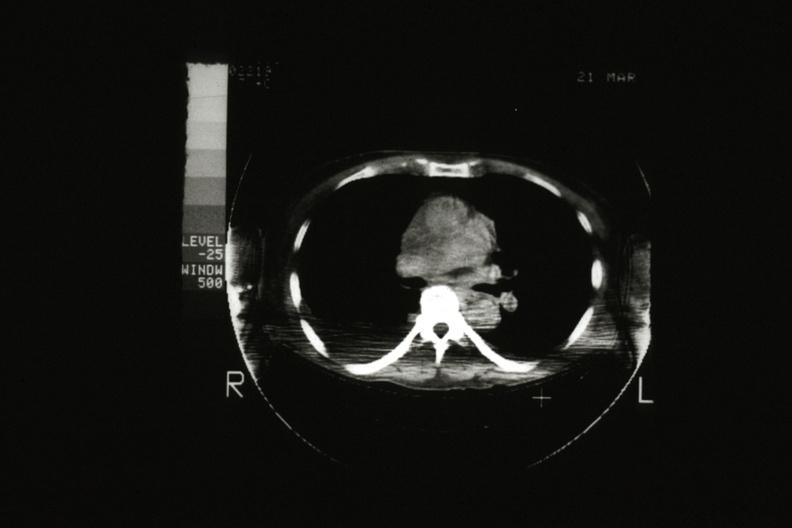s vasculitis foreign body present?
Answer the question using a single word or phrase. No 